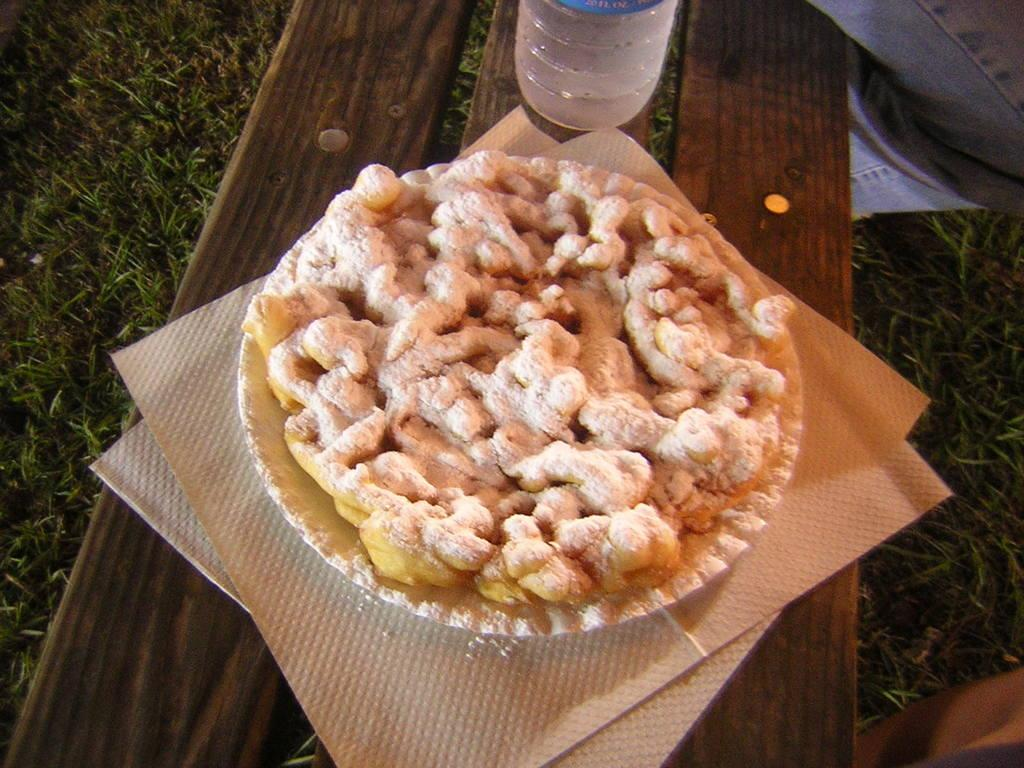What is on the plate in the image? There is a food item on a plate in the image. What can be used for cleaning or wiping in the image? Tissues are present in the image for cleaning or wiping. What is the beverage container in the image? There is a water bottle in the image. What type of surface is likely supporting the plate and other items? The wooden object is likely a table or surface. Whose legs are visible in the image? The legs of two persons are visible in the image. What type of natural environment is present in the image? There is grass in the image. What type of star can be seen shining brightly in the image? There is no star visible in the image; it features a food item on a plate, tissues, a water bottle, a wooden object, and grass. What type of pipe is being used by the persons in the image? There is no pipe present in the image; only the legs of two persons are visible. 